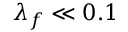Convert formula to latex. <formula><loc_0><loc_0><loc_500><loc_500>\lambda _ { f } \ll 0 . 1</formula> 